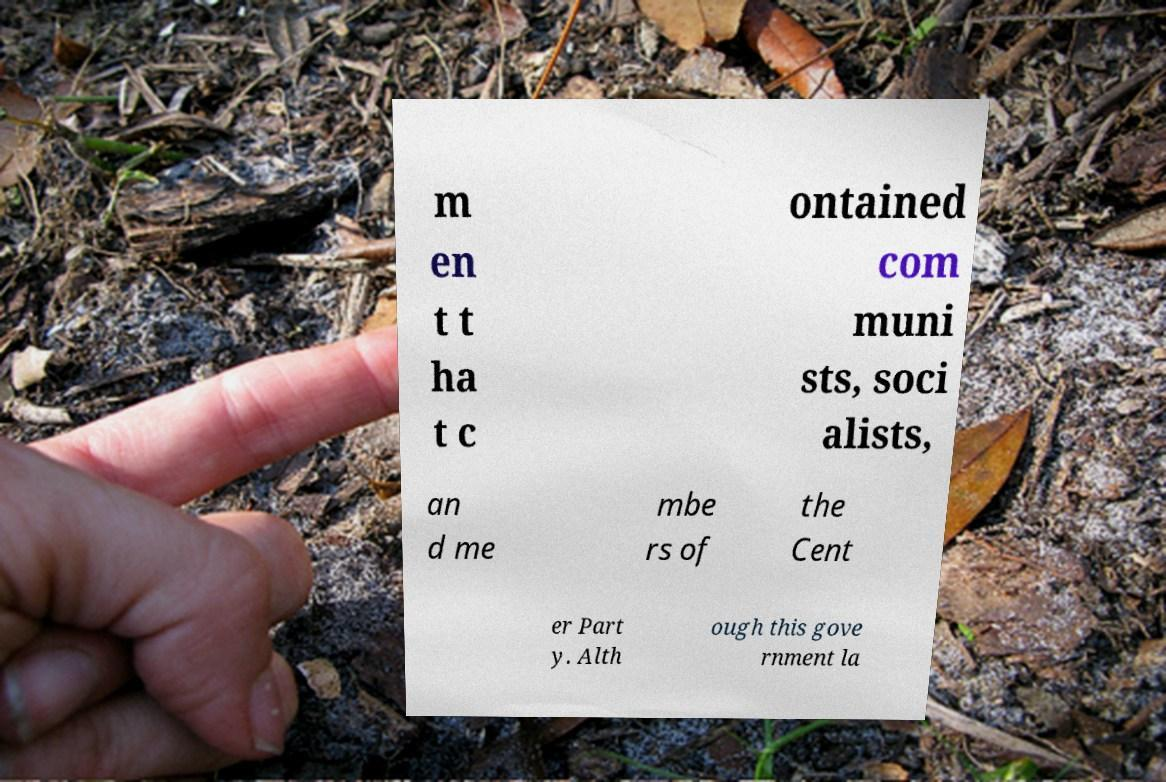There's text embedded in this image that I need extracted. Can you transcribe it verbatim? m en t t ha t c ontained com muni sts, soci alists, an d me mbe rs of the Cent er Part y. Alth ough this gove rnment la 